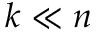Convert formula to latex. <formula><loc_0><loc_0><loc_500><loc_500>k \ll n</formula> 